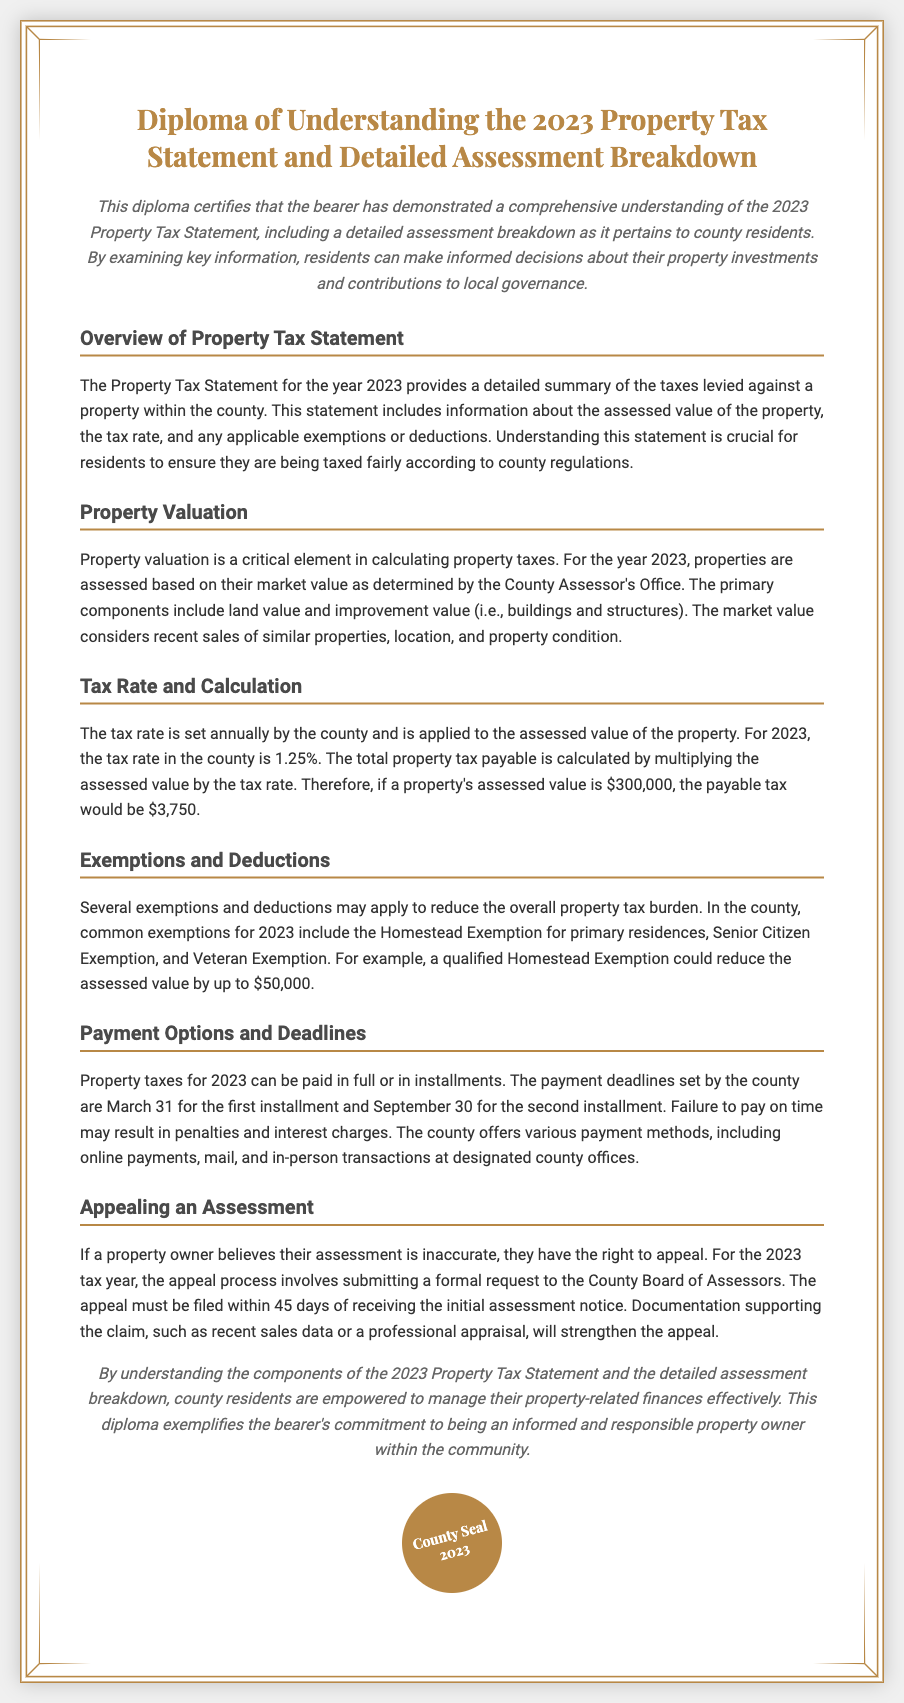What is the tax rate for 2023? The tax rate set by the county for 2023 is stated in the document as 1.25%.
Answer: 1.25% What is the deadline for the first installment payment? The payment deadline for the first installment in the document is mentioned as March 31.
Answer: March 31 What exemption can reduce the assessed value by up to $50,000? The document specifies the Homestead Exemption as the one that can reduce the assessed value by that amount.
Answer: Homestead Exemption How long do property owners have to appeal an assessment? The document states that property owners have 45 days to file an appeal after receiving the assessment notice.
Answer: 45 days What is the total property tax payable for an assessed value of $300,000? The document explains the calculation as the assessed value multiplied by the tax rate, resulting in $3,750.
Answer: $3,750 What is emphasized as essential for residents regarding the Property Tax Statement? The document highlights that understanding the Property Tax Statement is crucial to ensure fair taxation according to county regulations.
Answer: Fair taxation What is the purpose of this diploma? The diploma certifies a comprehensive understanding of the 2023 Property Tax Statement and detailed assessment breakdown.
Answer: Understanding of Property Tax Statement What is the consequence of failing to pay property taxes on time? The document mentions that failure to pay on time may result in penalties and interest charges.
Answer: Penalties and interest charges 